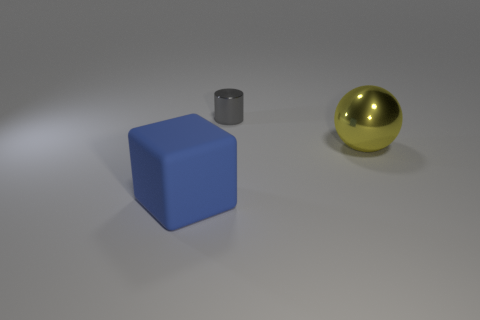Add 1 tiny gray metallic things. How many objects exist? 4 Subtract all cubes. How many objects are left? 2 Subtract all small metallic cylinders. Subtract all green things. How many objects are left? 2 Add 3 tiny metallic things. How many tiny metallic things are left? 4 Add 2 large balls. How many large balls exist? 3 Subtract 0 green cylinders. How many objects are left? 3 